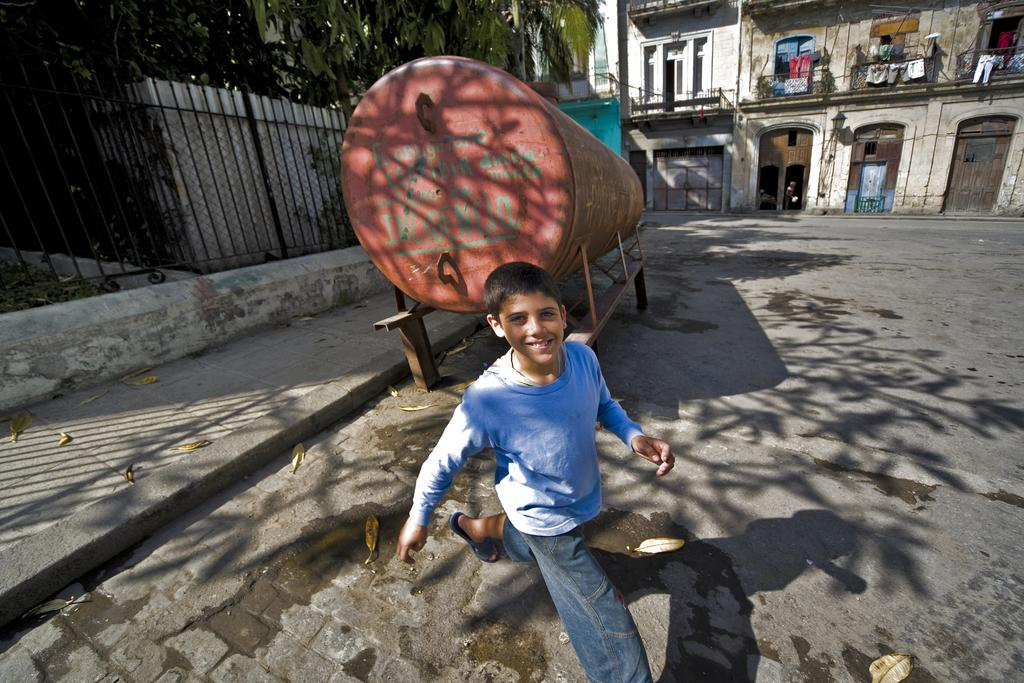What is the main subject of the image? The main subject of the image is a boy walking. What object can be seen in the image besides the boy? There is an object that looks like a container in the image. What type of natural environment is visible in the image? There are trees in the image. What can be seen in the background of the image? There is a building in the background of the image. How many deer are visible in the image? There are no deer present in the image. What type of organization is responsible for the container in the image? There is no information about an organization being responsible for the container in the image. 